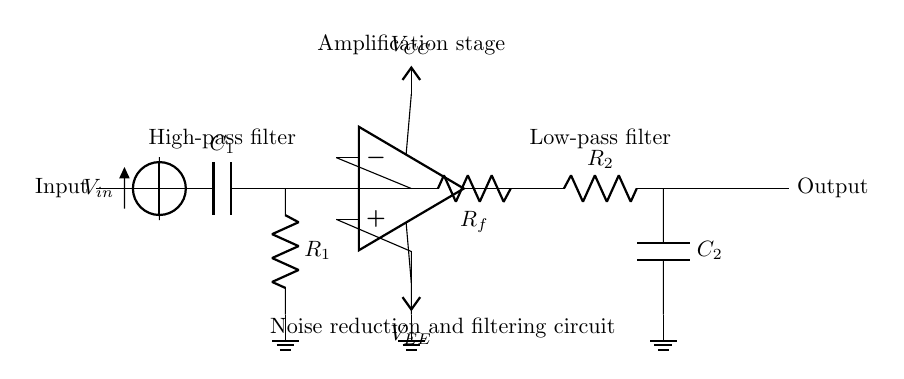What type of filter is used at the input? The circuit includes a high-pass filter at the input stage, which is represented by a capacitor and a resistor. The capacitor allows high-frequency signals to pass while blocking low-frequency signals.
Answer: high-pass filter What are the components used in the amplification stage? The amplification stage consists of an operational amplifier, which is utilized for increasing the magnitude of the input signal. It also has a feedback resistor connected to its output for controlling gain.
Answer: operational amplifier and feedback resistor What is the purpose of the low-pass filter in this circuit? The low-pass filter is employed to remove high-frequency noise from the signal after amplification. It consists of a resistor and capacitor in series that allow low-frequency signals to pass while attenuating high-frequency signals.
Answer: noise reduction What are the values of the voltage supplies for the operational amplifier? The operational amplifier is powered by two supply voltages: Vcc and Vee, which are typically positive and negative power supplies needed for the device to function effectively.
Answer: Vcc and Vee How many stages are there in this noise reduction circuit? The circuit has three main stages: the high-pass filter, the amplification stage, and the low-pass filter. Each stage serves a specific purpose for filtering and processing the input signal.
Answer: three stages What kind of coupling is at the output? The output is a direct connection to the next stage or system, with no additional filtering or processing indicated in the diagram. This allows for the processed signal to be made available for further use or analysis.
Answer: direct coupling 